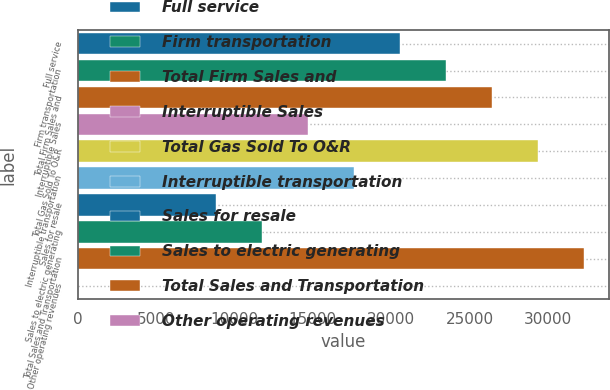Convert chart to OTSL. <chart><loc_0><loc_0><loc_500><loc_500><bar_chart><fcel>Full service<fcel>Firm transportation<fcel>Total Firm Sales and<fcel>Interruptible Sales<fcel>Total Gas Sold To O&R<fcel>Interruptible transportation<fcel>Sales for resale<fcel>Sales to electric generating<fcel>Total Sales and Transportation<fcel>Other operating revenues<nl><fcel>20545.9<fcel>23479.6<fcel>26413.3<fcel>14678.5<fcel>29347<fcel>17612.2<fcel>8811.1<fcel>11744.8<fcel>32280.7<fcel>10<nl></chart> 